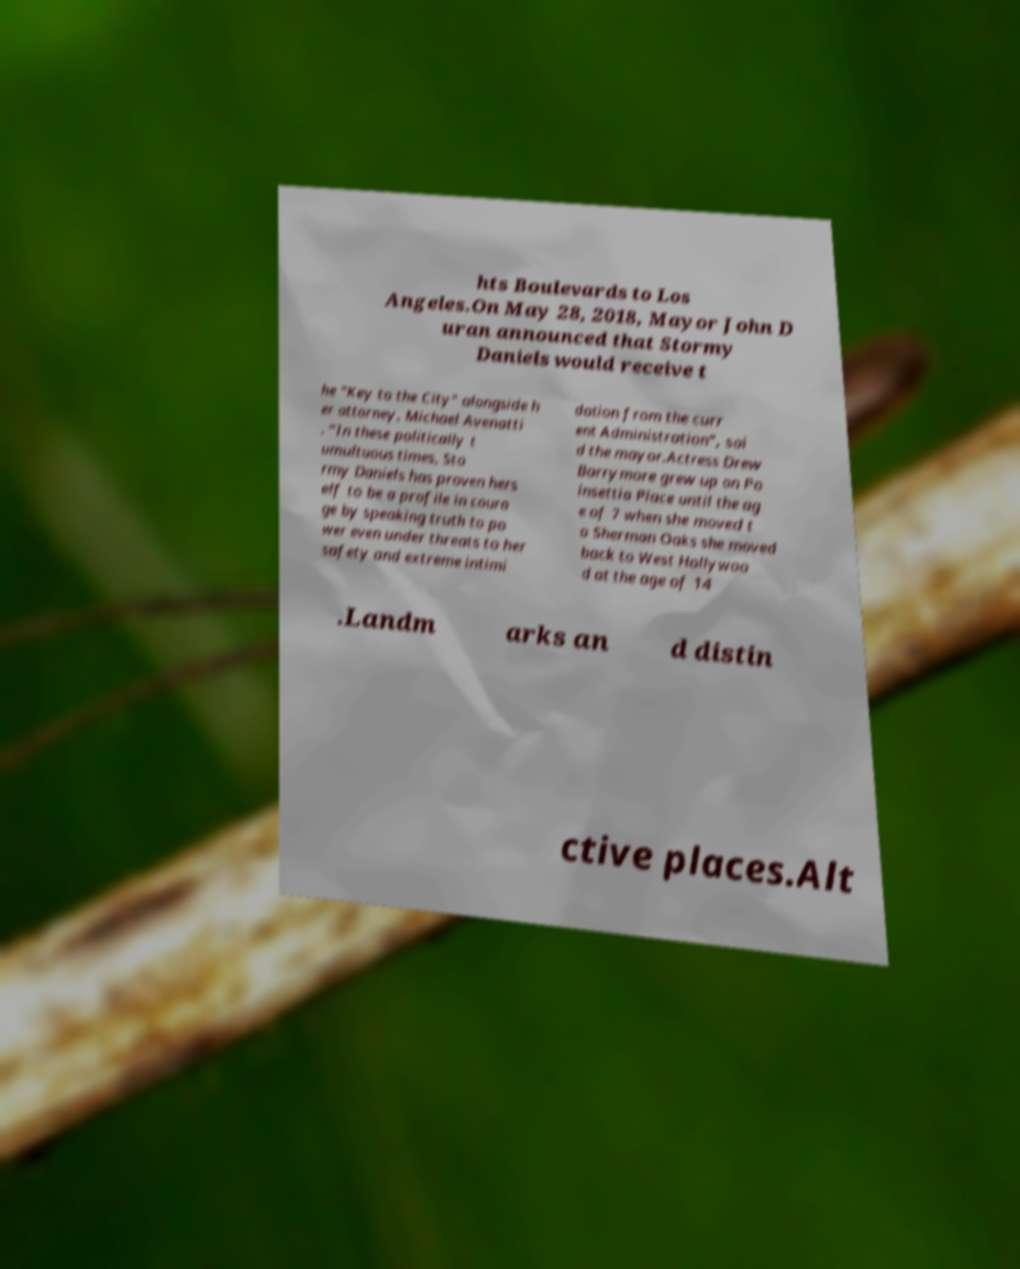For documentation purposes, I need the text within this image transcribed. Could you provide that? hts Boulevards to Los Angeles.On May 28, 2018, Mayor John D uran announced that Stormy Daniels would receive t he "Key to the City" alongside h er attorney, Michael Avenatti . “In these politically t umultuous times, Sto rmy Daniels has proven hers elf to be a profile in coura ge by speaking truth to po wer even under threats to her safety and extreme intimi dation from the curr ent Administration”, sai d the mayor.Actress Drew Barrymore grew up on Po insettia Place until the ag e of 7 when she moved t o Sherman Oaks she moved back to West Hollywoo d at the age of 14 .Landm arks an d distin ctive places.Alt 